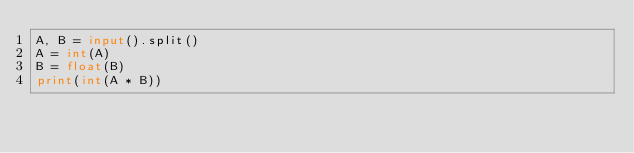Convert code to text. <code><loc_0><loc_0><loc_500><loc_500><_Python_>A, B = input().split()
A = int(A)
B = float(B)
print(int(A * B))
</code> 